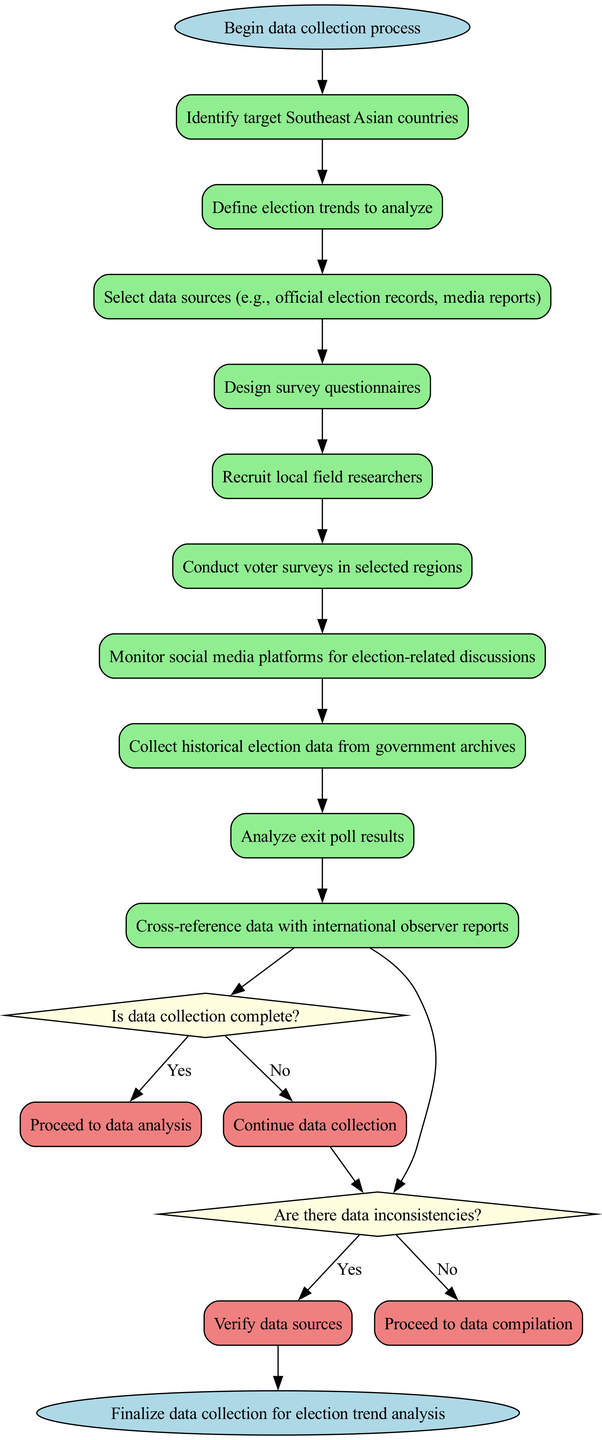What is the first activity in the diagram? The first activity node in the diagram is directly connected to the start node, indicating the beginning of the process. By observing the nodes and edges, we can see "Identify target Southeast Asian countries" is the initial action to be taken.
Answer: Identify target Southeast Asian countries How many activities are present in the diagram? By counting the nodes that represent activities in the diagram, we see there are a total of 10 activities listed in the activities section. This can be confirmed by reviewing the sequence of rectangles in the flow.
Answer: 10 What is the last decision point in the diagram? Observing the flowchart, we note that the last decision node is related to checking data inconsistencies before proceeding with data compilation. The questioning of "Are there data inconsistencies?" represents the final decision before the conclusion of the process.
Answer: Are there data inconsistencies? What happens if data collection is incomplete? Following the flow of the diagram, if data collection is not complete, it leads back to continuing the data collection process. This is clearly outlined in the decision "Is data collection complete?" which, if answered "no," directs the process back to further collection.
Answer: Continue data collection How many edges lead out from the last activity? Looking at the last activity node, which is "Cross-reference data with international observer reports," we count how many edges connect it to subsequent nodes. There are two edges leading out, one to the decision point and one leading to the conclusion if the decision is affirmative.
Answer: 2 What does the "yes" path of the last decision result in? Evaluating the "yes" flow from the last decision, which checks for data inconsistencies, leads directly to the next step which is the data compilation process, indicating a successful resolution of any inconsistencies.
Answer: Proceed to data compilation What is the goal of this activity diagram? The overall objective of the activity diagram is summarized at the end node, which states the conclusion is to finalize the data collection for election trend analysis. This summarization is essential to understand the purpose of the preceding activities and decisions.
Answer: Finalize data collection for election trend analysis What follows after the activity of conducting voter surveys? After reviewing the activity of conducting voter surveys, the next node indicates monitoring social media platforms for election-related discussions. This gives insight into additional methods of data gathering and complementing survey results.
Answer: Monitor social media platforms for election-related discussions 